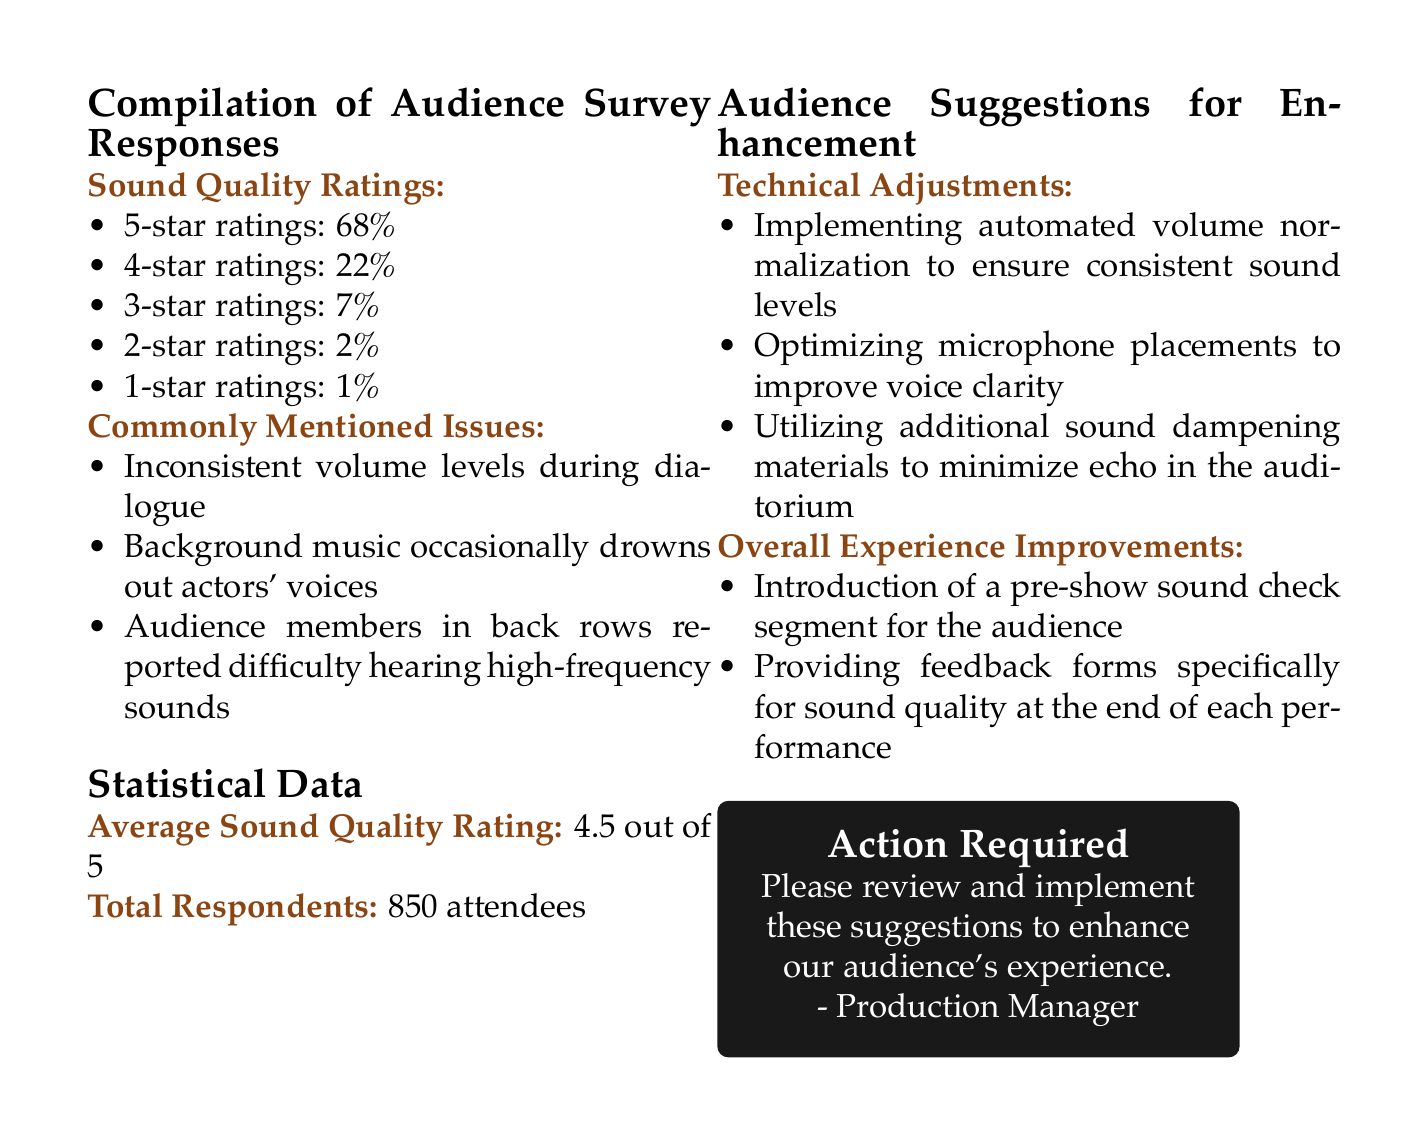What percentage of respondents gave a 5-star rating? The document states that 68% of respondents gave a 5-star rating.
Answer: 68% What is the average sound quality rating? The document indicates an average sound quality rating of 4.5 out of 5.
Answer: 4.5 out of 5 How many attendees responded to the survey? The total number of attendees who responded is mentioned as 850.
Answer: 850 What specific issue was mentioned regarding volume levels? The document highlights that there were inconsistent volume levels during dialogue.
Answer: Inconsistent volume levels during dialogue What suggestion was made for optimizing microphone placements? The document suggests optimizing microphone placements to improve voice clarity.
Answer: Improve voice clarity What type of sound enhancement materials are suggested? Audience suggestions highlight utilizing additional sound dampening materials.
Answer: Additional sound dampening materials What improvement is suggested for overall experience? The document mentions the introduction of a pre-show sound check segment for the audience.
Answer: Pre-show sound check segment What was the second-highest star rating received? The document indicates that the second-highest star rating received was 4-star ratings at 22%.
Answer: 22% What action is requested in the document? The document requests to review and implement the suggestions to enhance the audience's experience.
Answer: Review and implement suggestions 